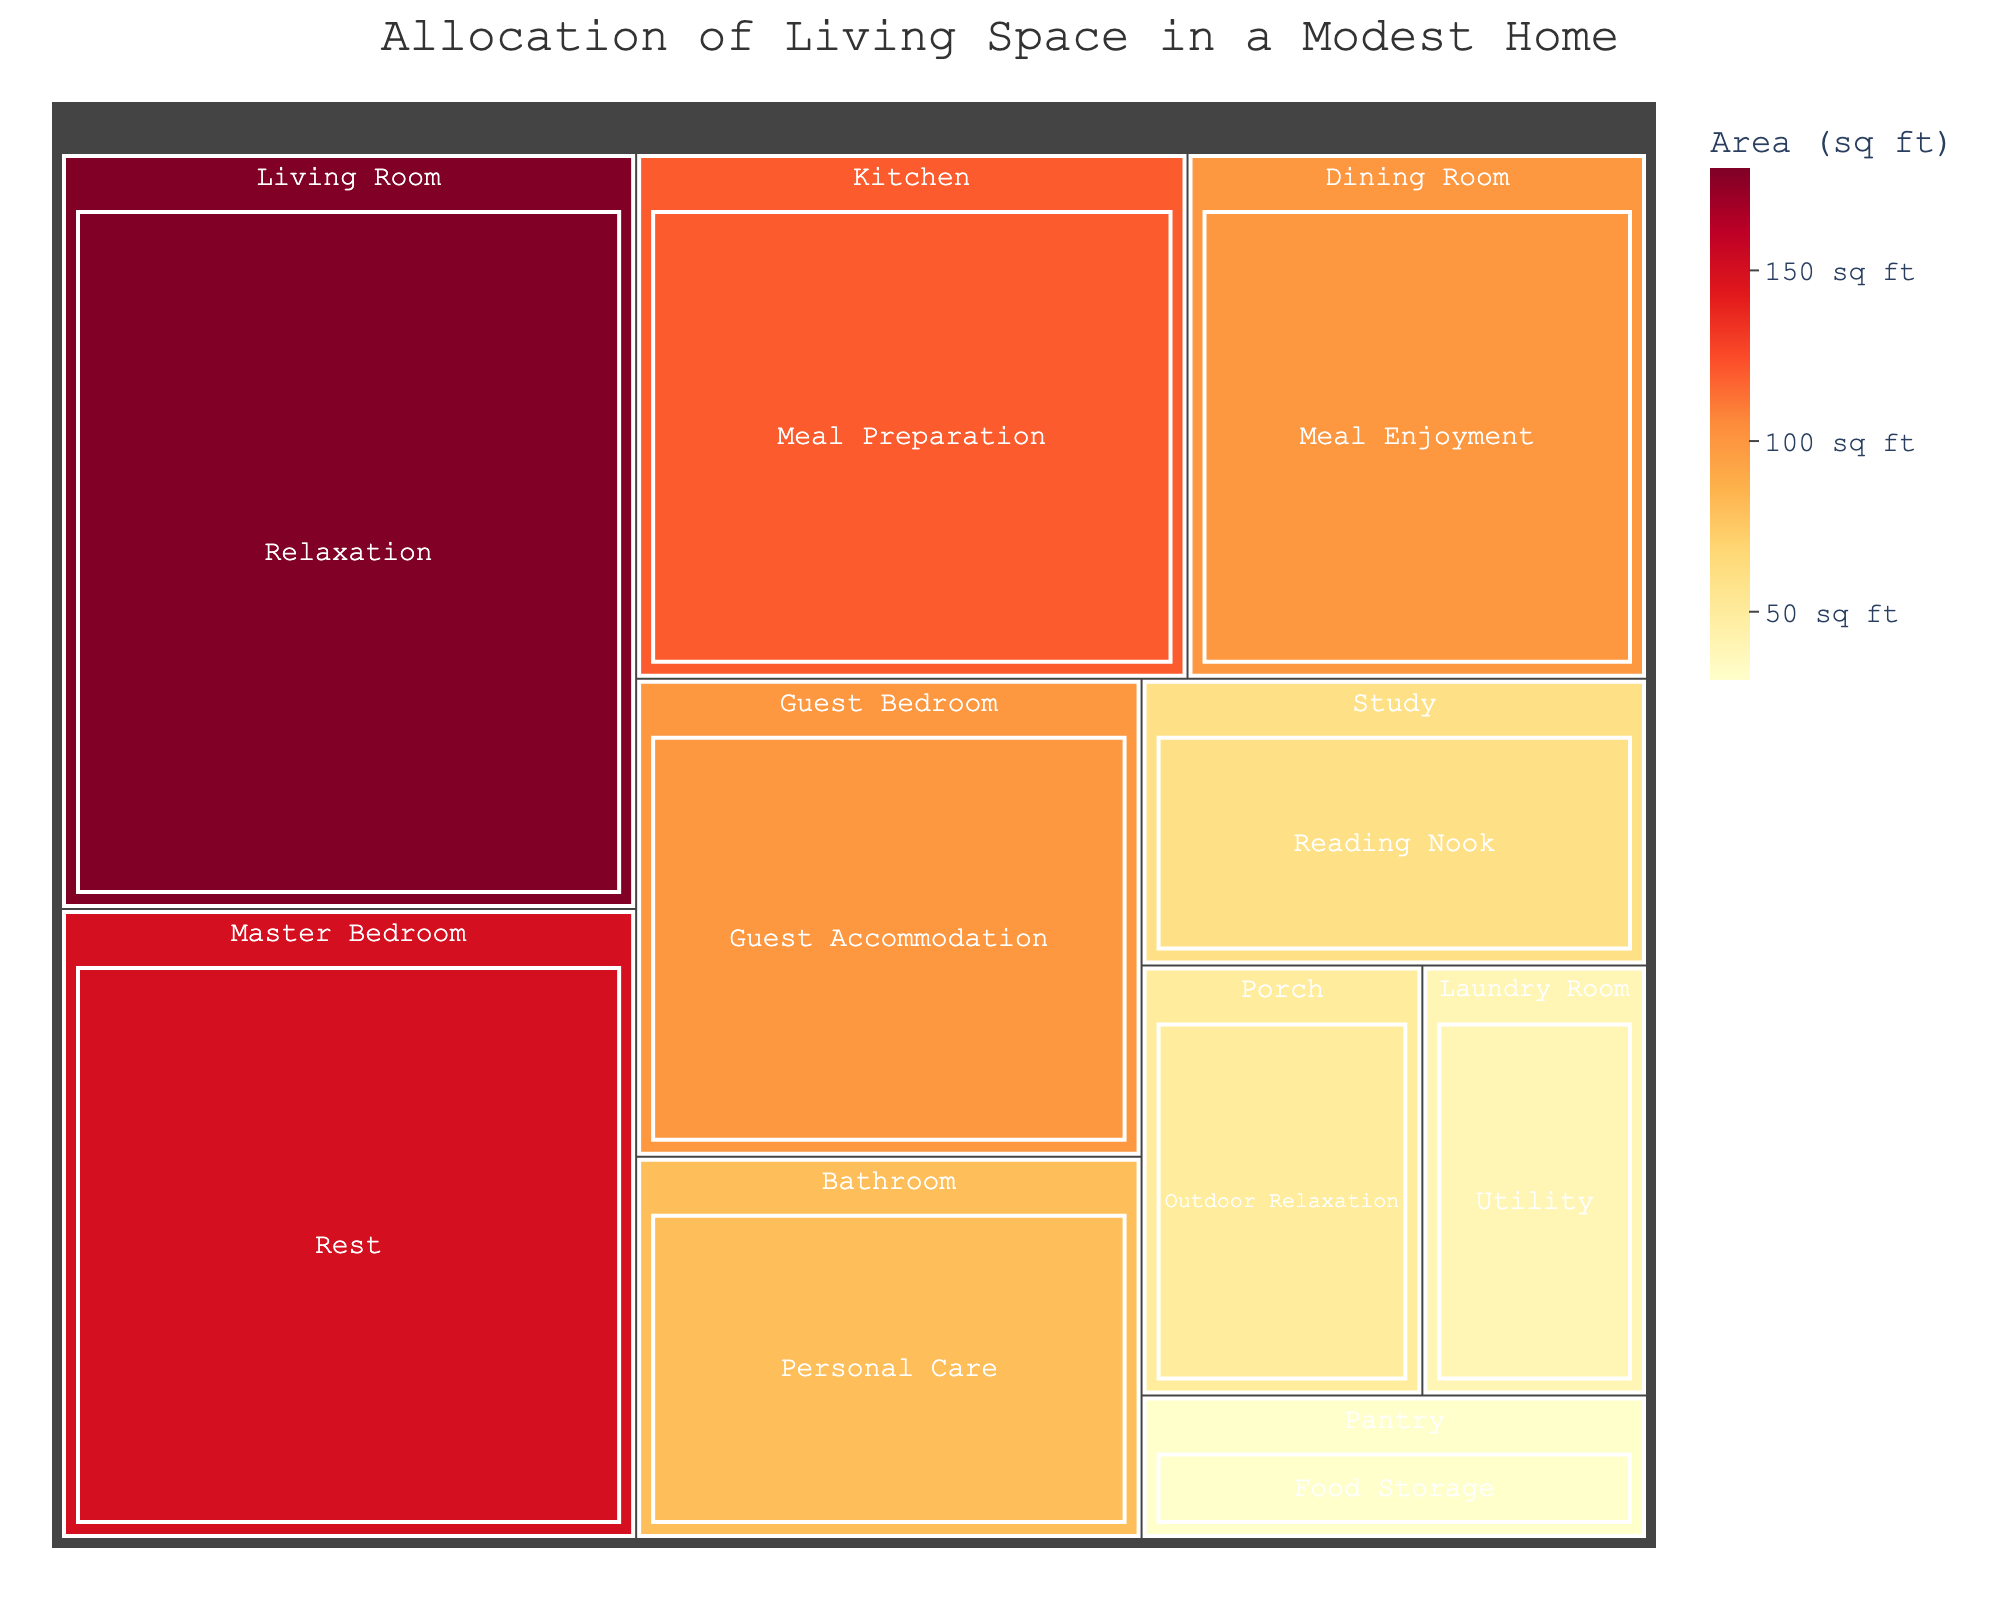What's the title of the treemap? The title can be found at the top of the treemap, it reads “Allocation of Living Space in a Modest Home”.
Answer: Allocation of Living Space in a Modest Home How many unique categories are displayed in the treemap? Each unique color represents a different category, and there are 9 distinct sections in the treemap.
Answer: 9 Which space has the largest area? By comparing the areas visually, the Living Room has the largest section in the treemap.
Answer: Living Room What is the combined area of the Kitchen and Dining Room? Find the areas for both the Kitchen (120 sq ft) and Dining Room (100 sq ft), then sum them: 120 + 100 = 220 sq ft.
Answer: 220 sq ft Which area occupies more space: the Master Bedroom or the Guest Bedroom? Compare the areas of the Master Bedroom (150 sq ft) and the Guest Bedroom (100 sq ft), the Master Bedroom is larger.
Answer: Master Bedroom How much space is allocated to relaxation (Living Room and Porch together) in total? Sum the areas of the Living Room (180 sq ft) and the Porch (50 sq ft): 180 + 50 = 230 sq ft.
Answer: 230 sq ft What is the average area of all spaces dedicated to meal-related activities? Meal-related spaces are the Kitchen (120 sq ft) and Dining Room (100 sq ft). Average area = (120 + 100) / 2 = 220 / 2 = 110 sq ft.
Answer: 110 sq ft Which has a larger area: the Pantry or the Laundry Room? Compare the areas of the Pantry (30 sq ft) and Laundry Room (40 sq ft); the Laundry Room is larger.
Answer: Laundry Room What’s the difference in area between the Living Room and the Study? Subtract the area of the Study (60 sq ft) from the Living Room (180 sq ft): 180 - 60 = 120 sq ft.
Answer: 120 sq ft 